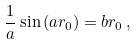<formula> <loc_0><loc_0><loc_500><loc_500>\frac { 1 } { a } \sin { ( a r _ { 0 } ) } = b r _ { 0 } \, ,</formula> 